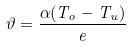Convert formula to latex. <formula><loc_0><loc_0><loc_500><loc_500>\vartheta = \frac { \alpha ( T _ { o } - T _ { u } ) } { e }</formula> 